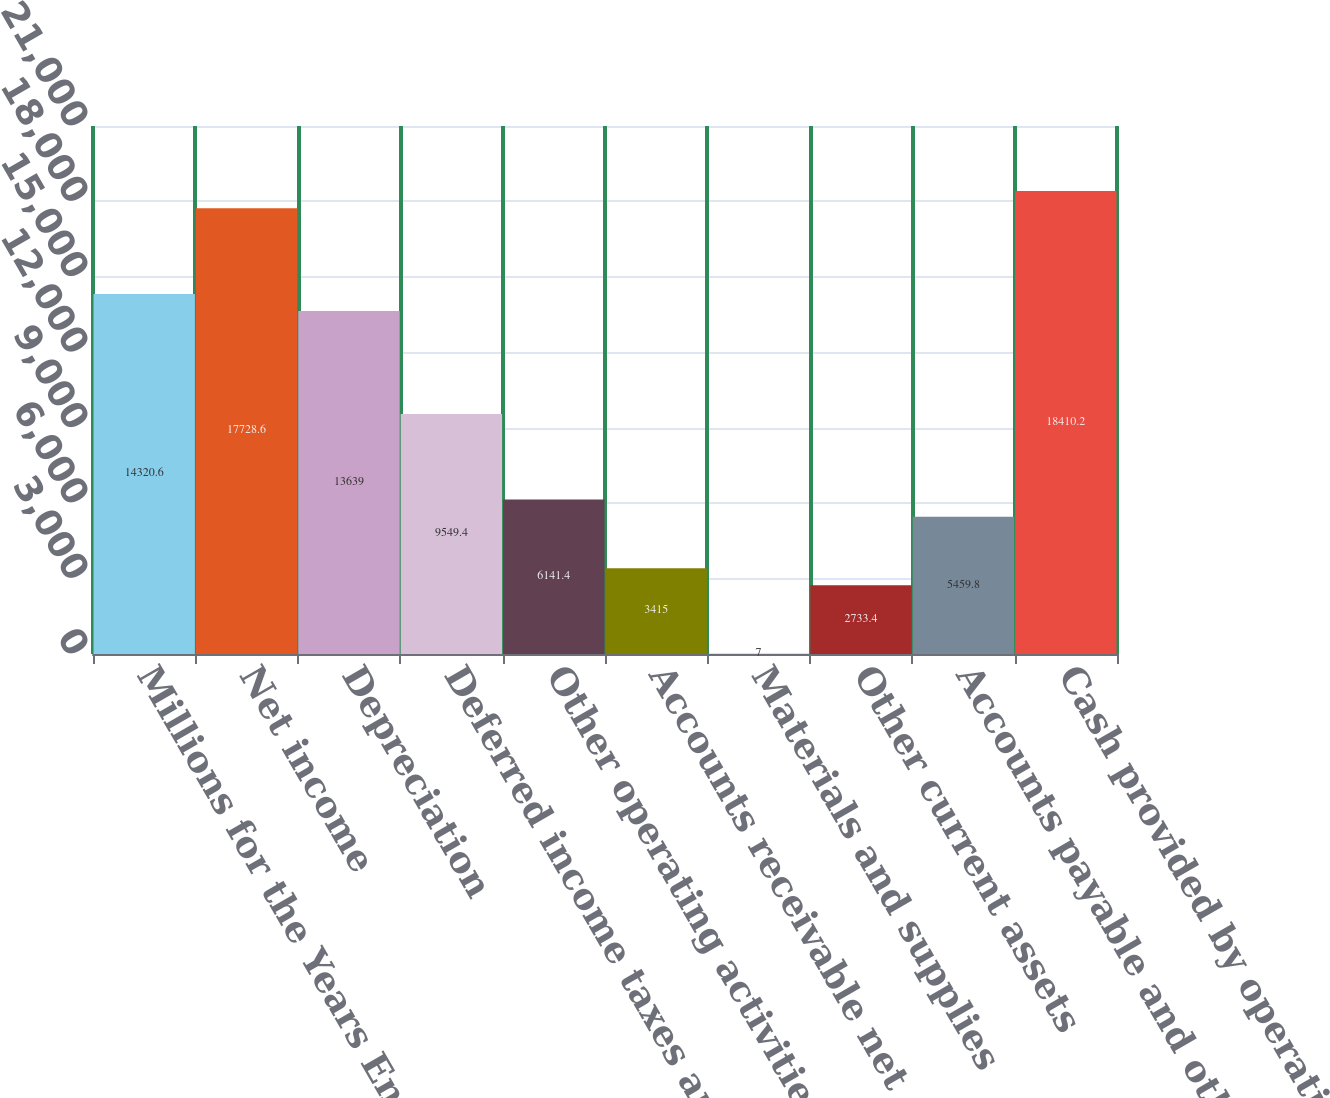Convert chart. <chart><loc_0><loc_0><loc_500><loc_500><bar_chart><fcel>Millions for the Years Ended<fcel>Net income<fcel>Depreciation<fcel>Deferred income taxes and<fcel>Other operating activities net<fcel>Accounts receivable net<fcel>Materials and supplies<fcel>Other current assets<fcel>Accounts payable and other<fcel>Cash provided by operating<nl><fcel>14320.6<fcel>17728.6<fcel>13639<fcel>9549.4<fcel>6141.4<fcel>3415<fcel>7<fcel>2733.4<fcel>5459.8<fcel>18410.2<nl></chart> 